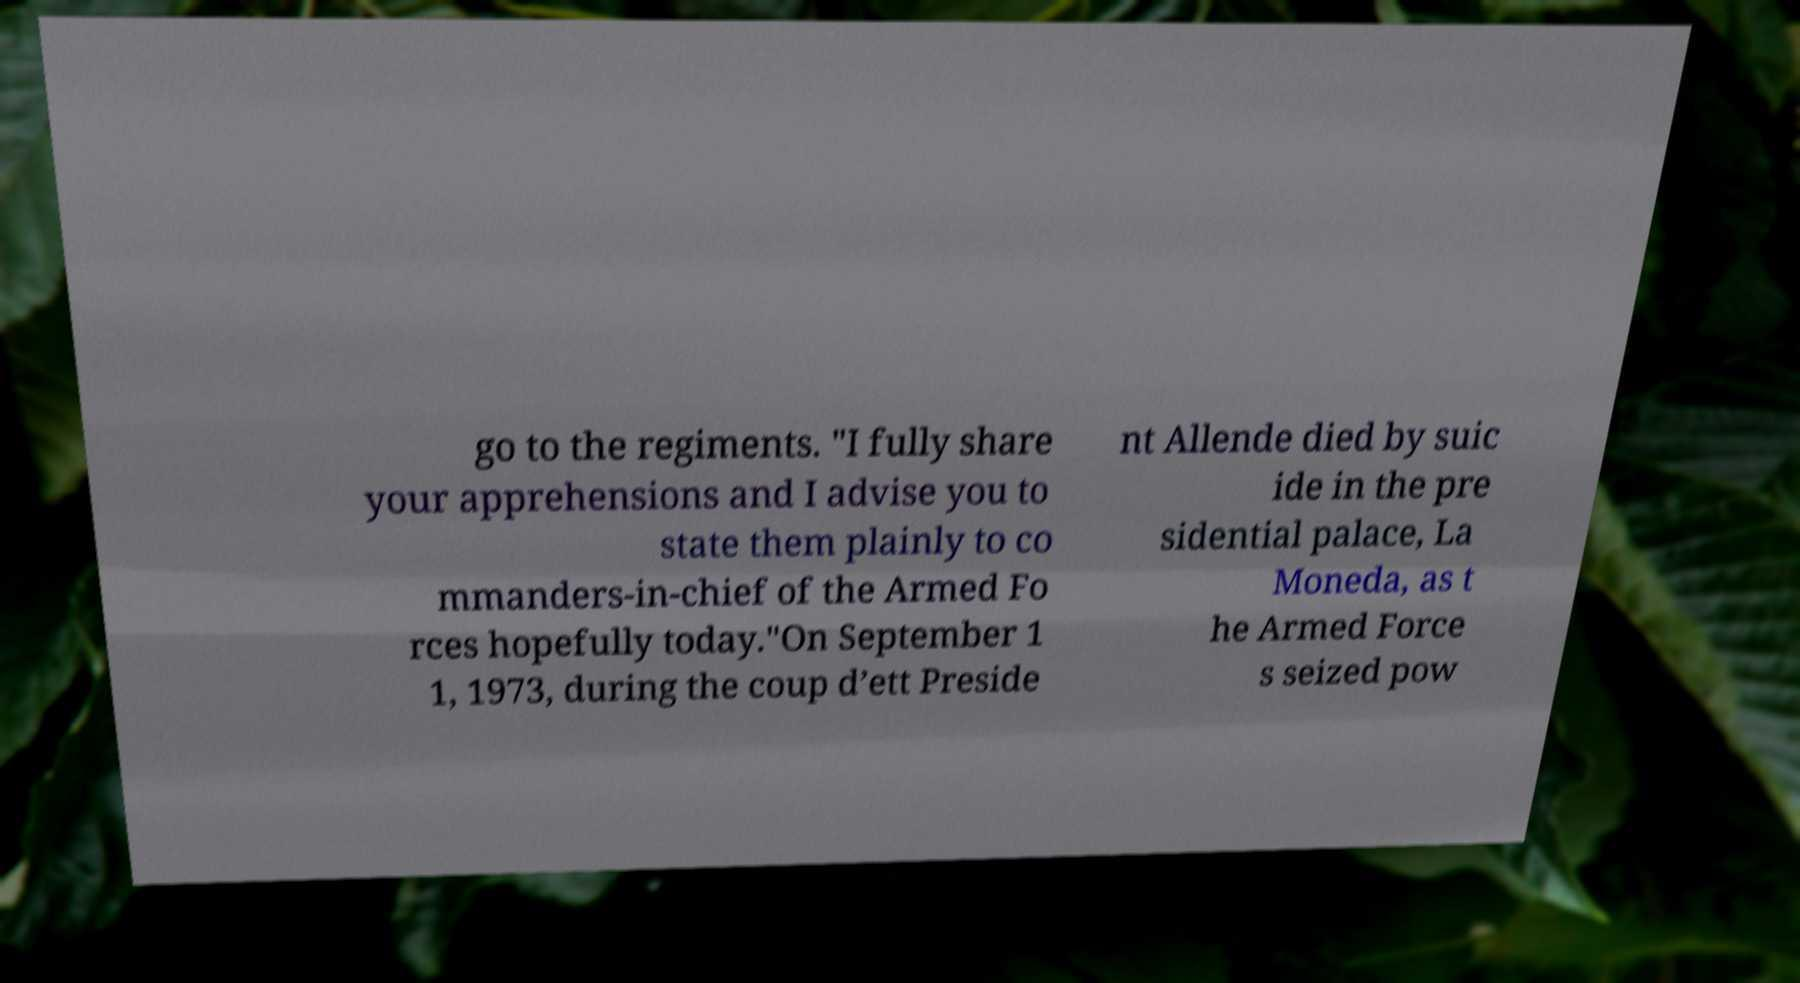Could you assist in decoding the text presented in this image and type it out clearly? go to the regiments. "I fully share your apprehensions and I advise you to state them plainly to co mmanders-in-chief of the Armed Fo rces hopefully today."On September 1 1, 1973, during the coup d’ett Preside nt Allende died by suic ide in the pre sidential palace, La Moneda, as t he Armed Force s seized pow 